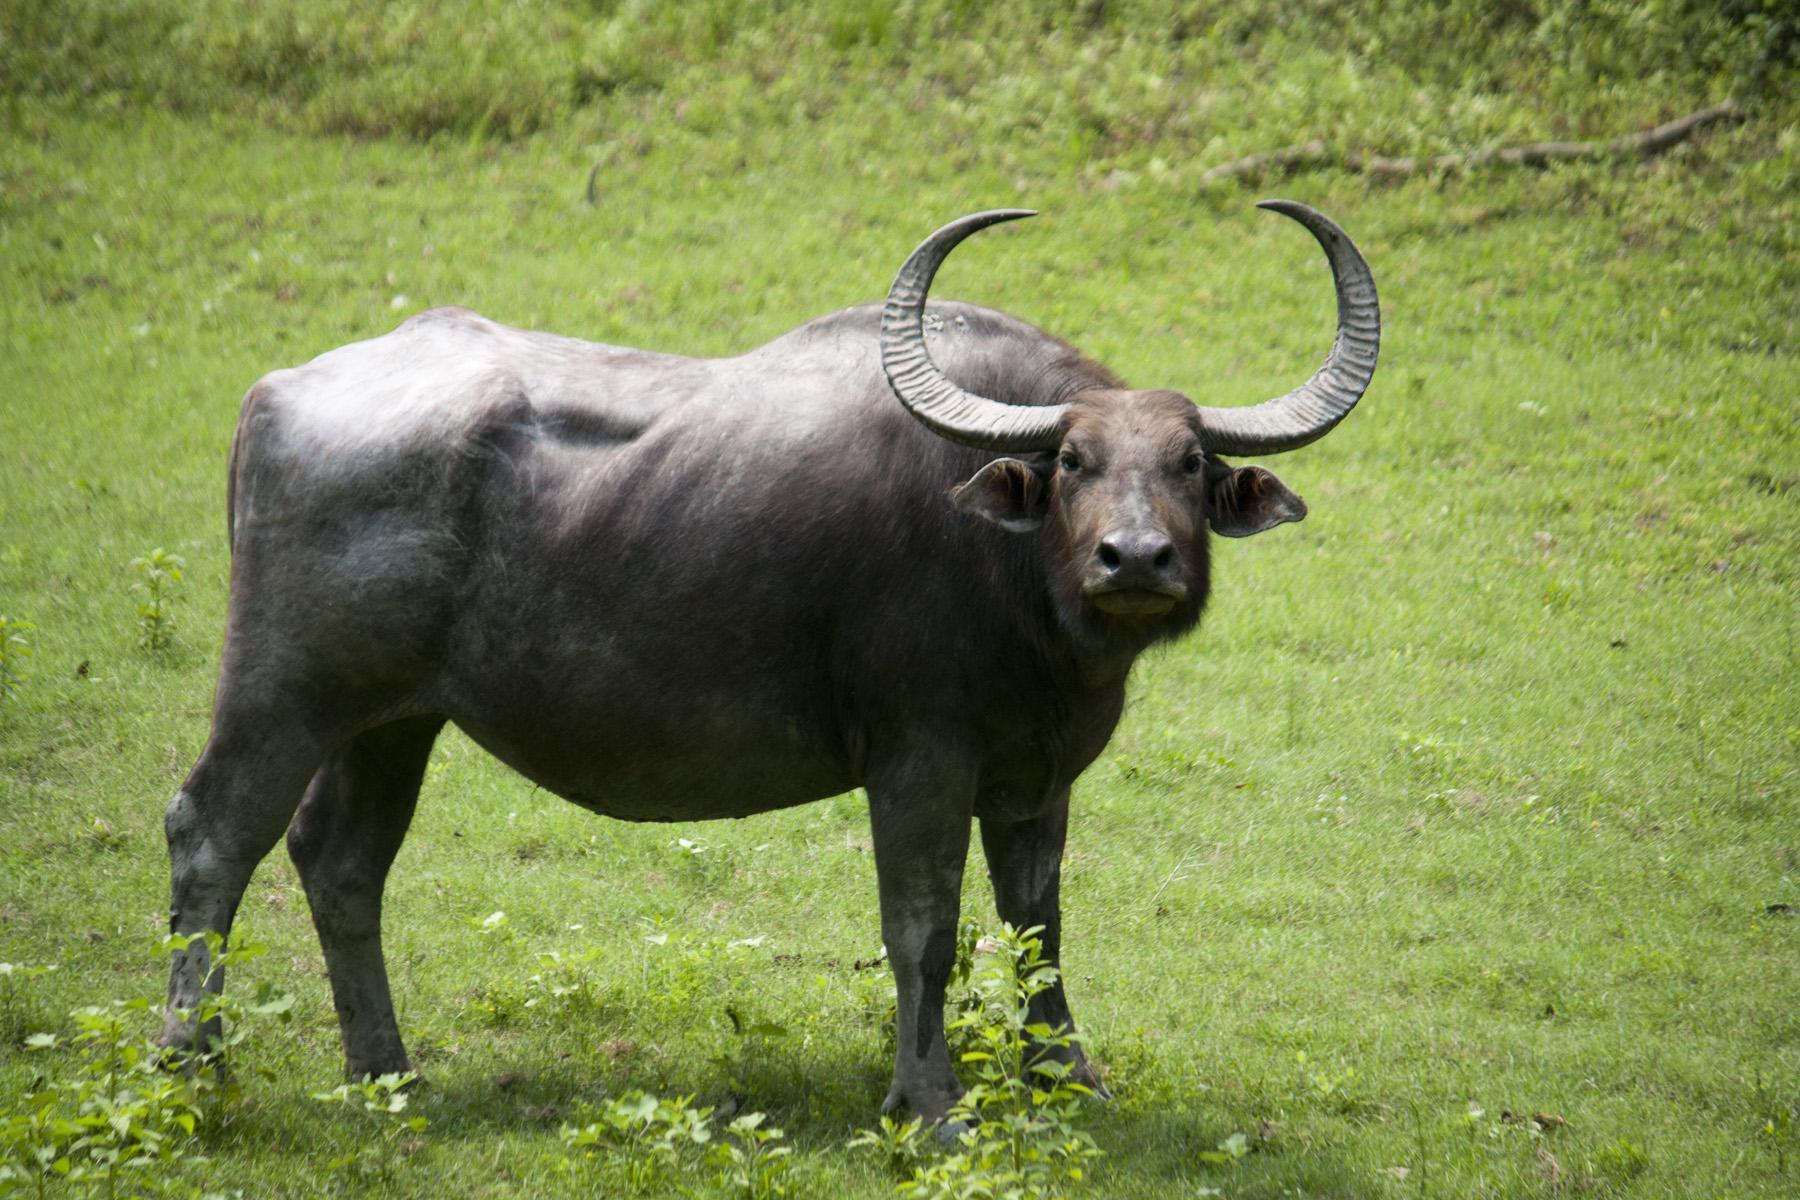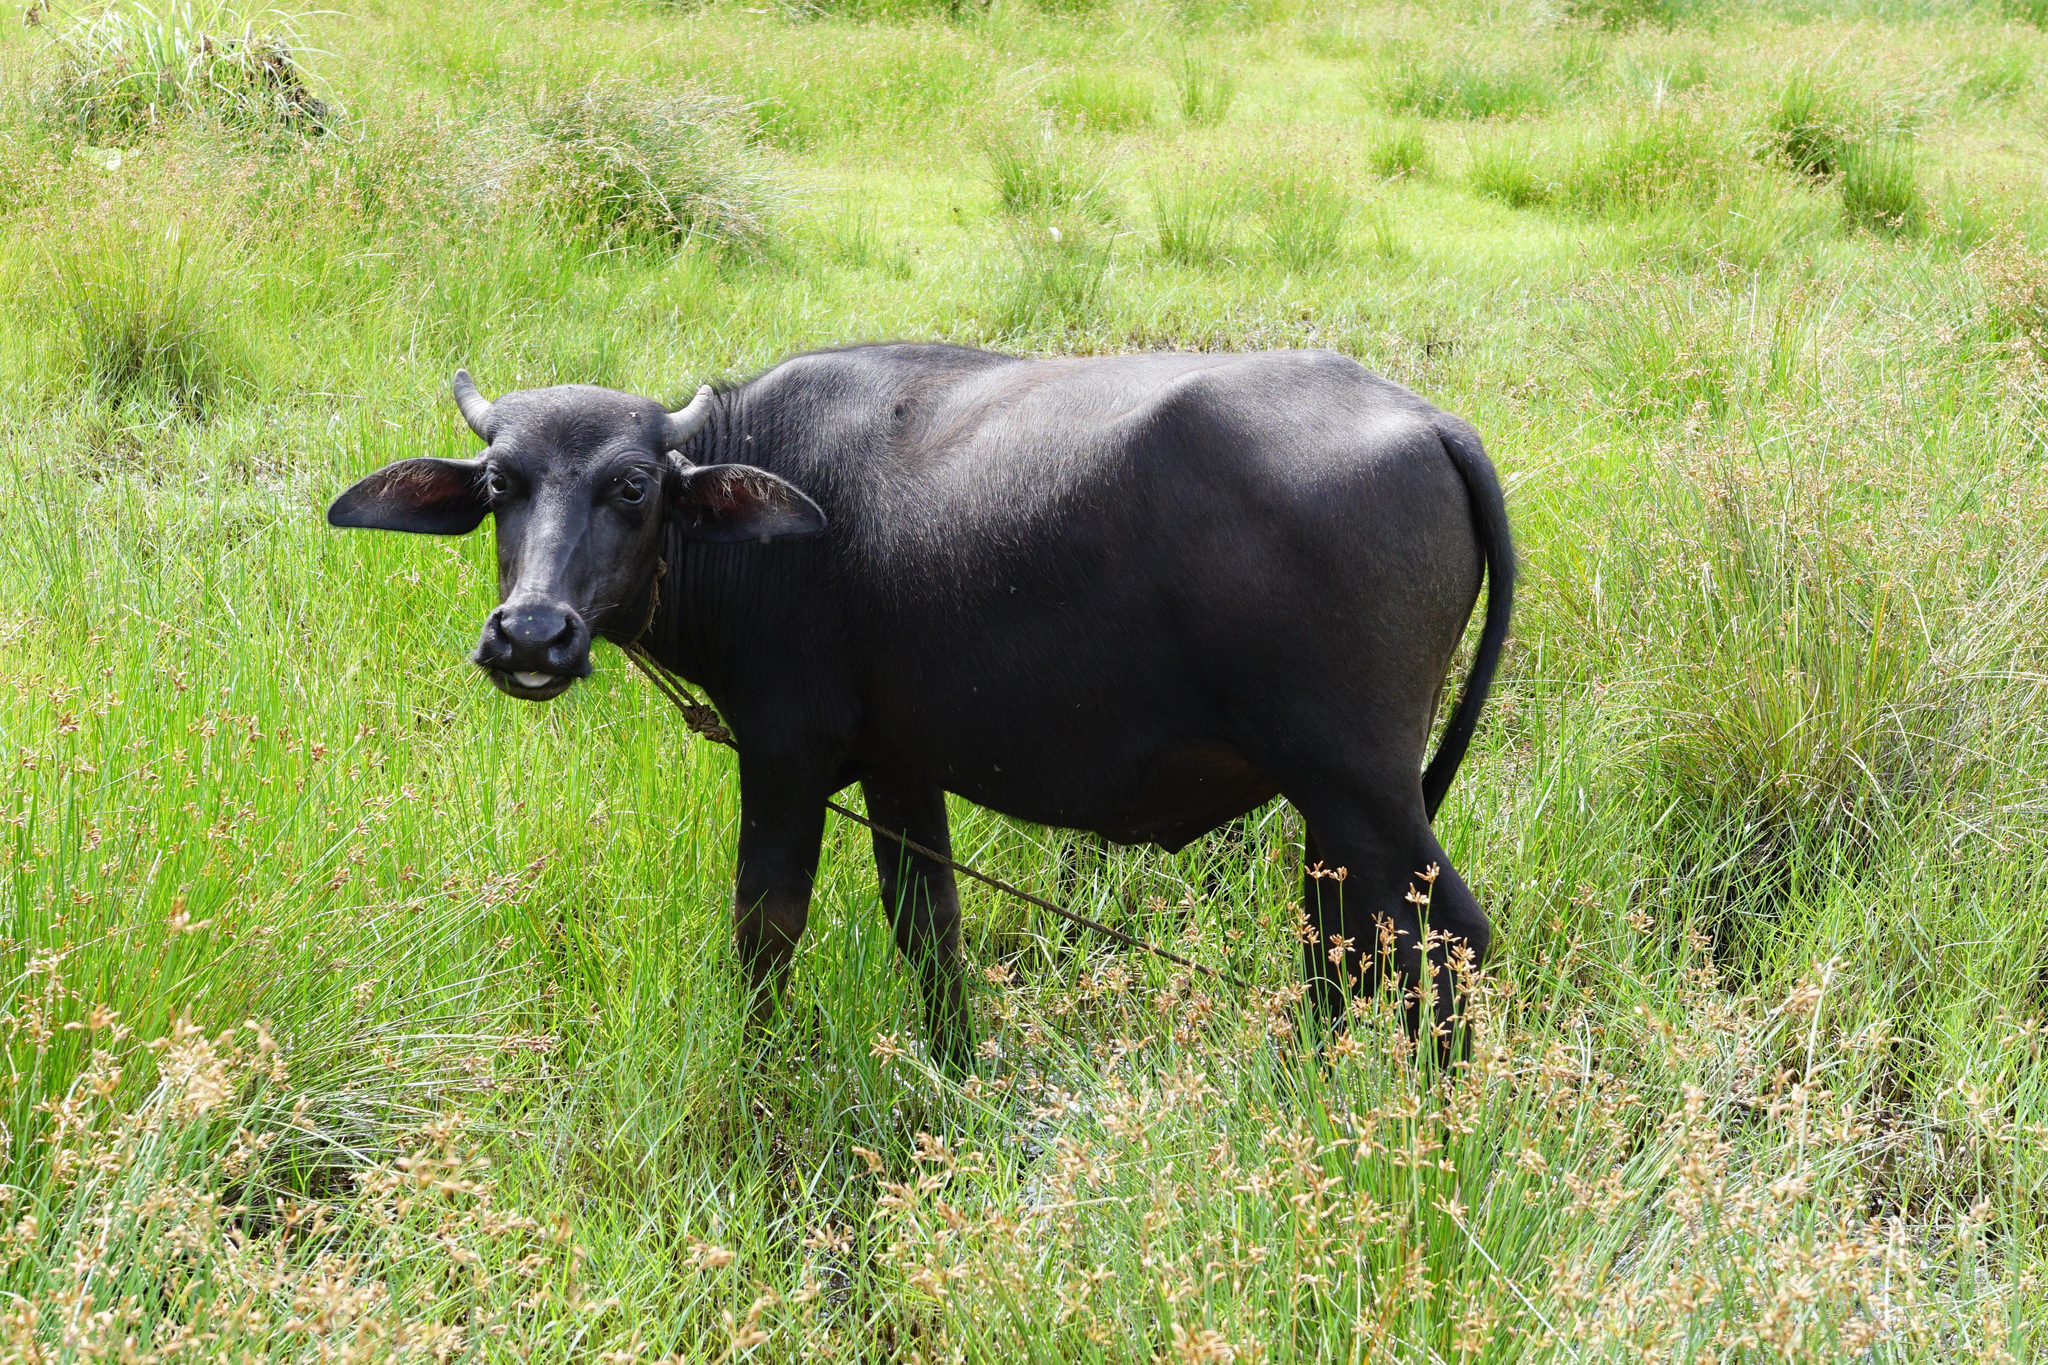The first image is the image on the left, the second image is the image on the right. Given the left and right images, does the statement "There is a single black buffalo with horns over a foot long facing left in a field of grass." hold true? Answer yes or no. No. The first image is the image on the left, the second image is the image on the right. Examine the images to the left and right. Is the description "Is one of the image there is a water buffalo standing in the water." accurate? Answer yes or no. No. 